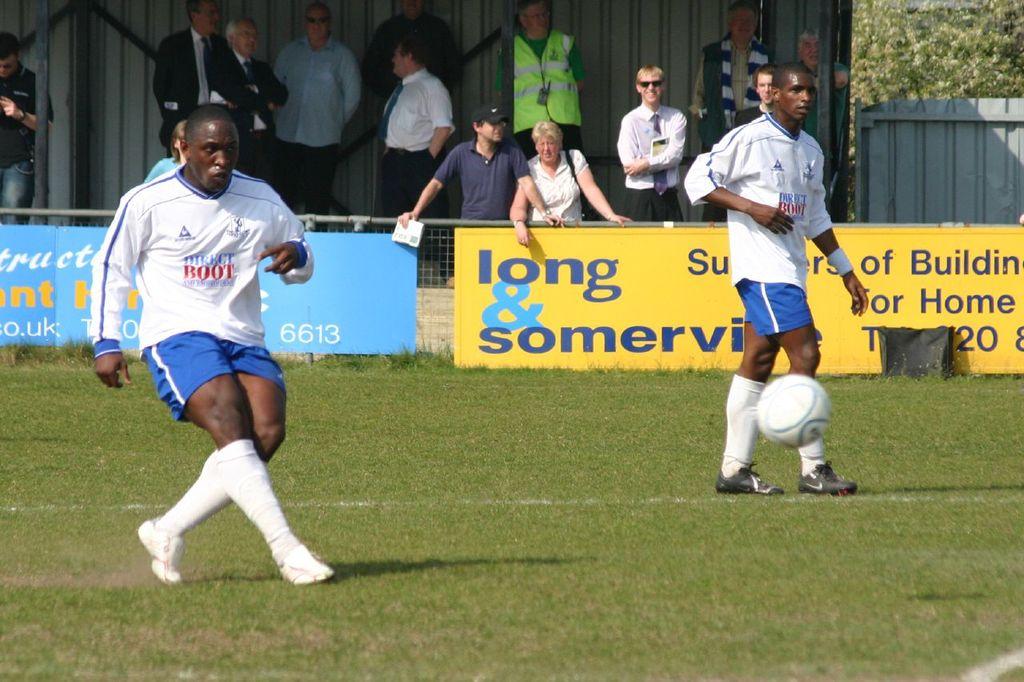What's the red word on their jerseys?
Offer a terse response. Boot. What number is on the blue banner?
Offer a very short reply. 6613. 